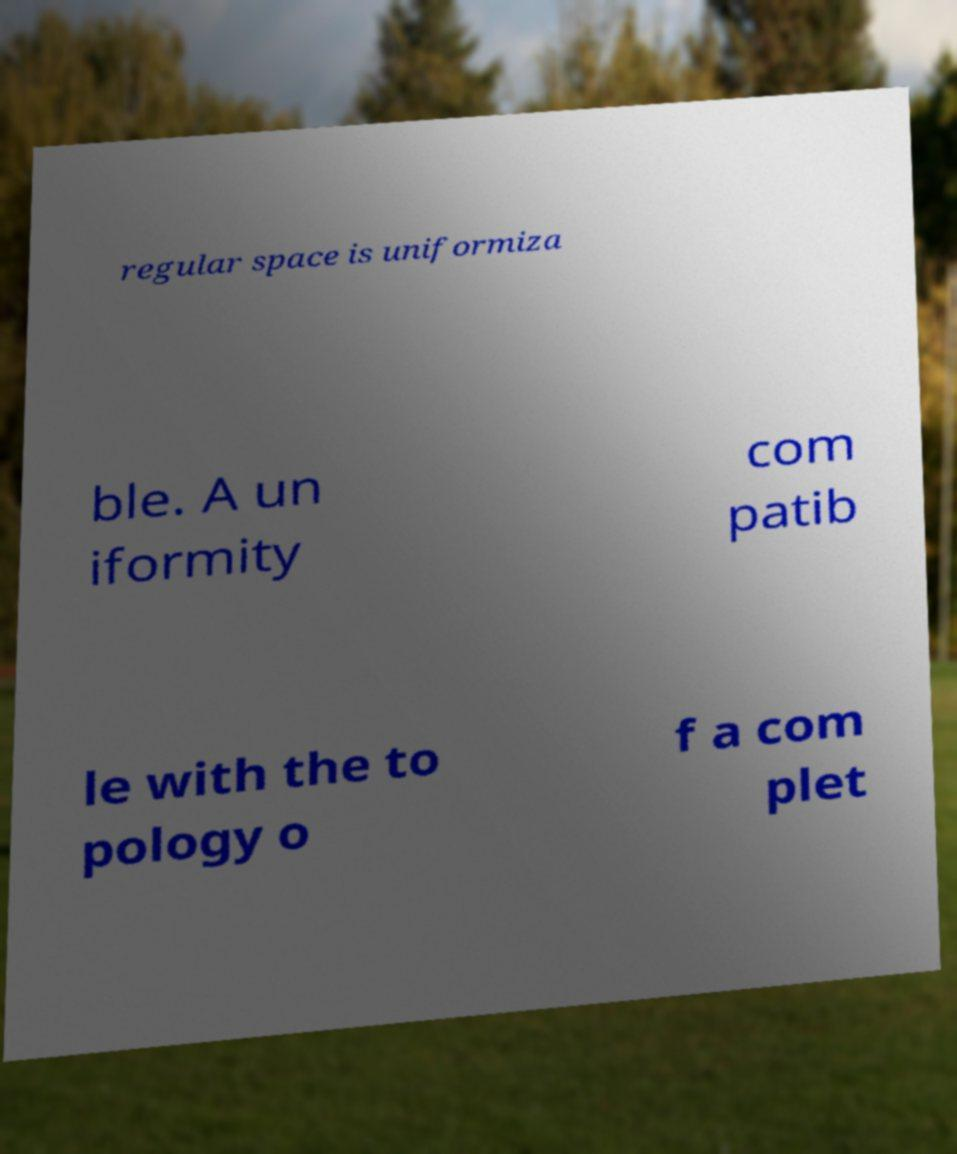Please read and relay the text visible in this image. What does it say? regular space is uniformiza ble. A un iformity com patib le with the to pology o f a com plet 